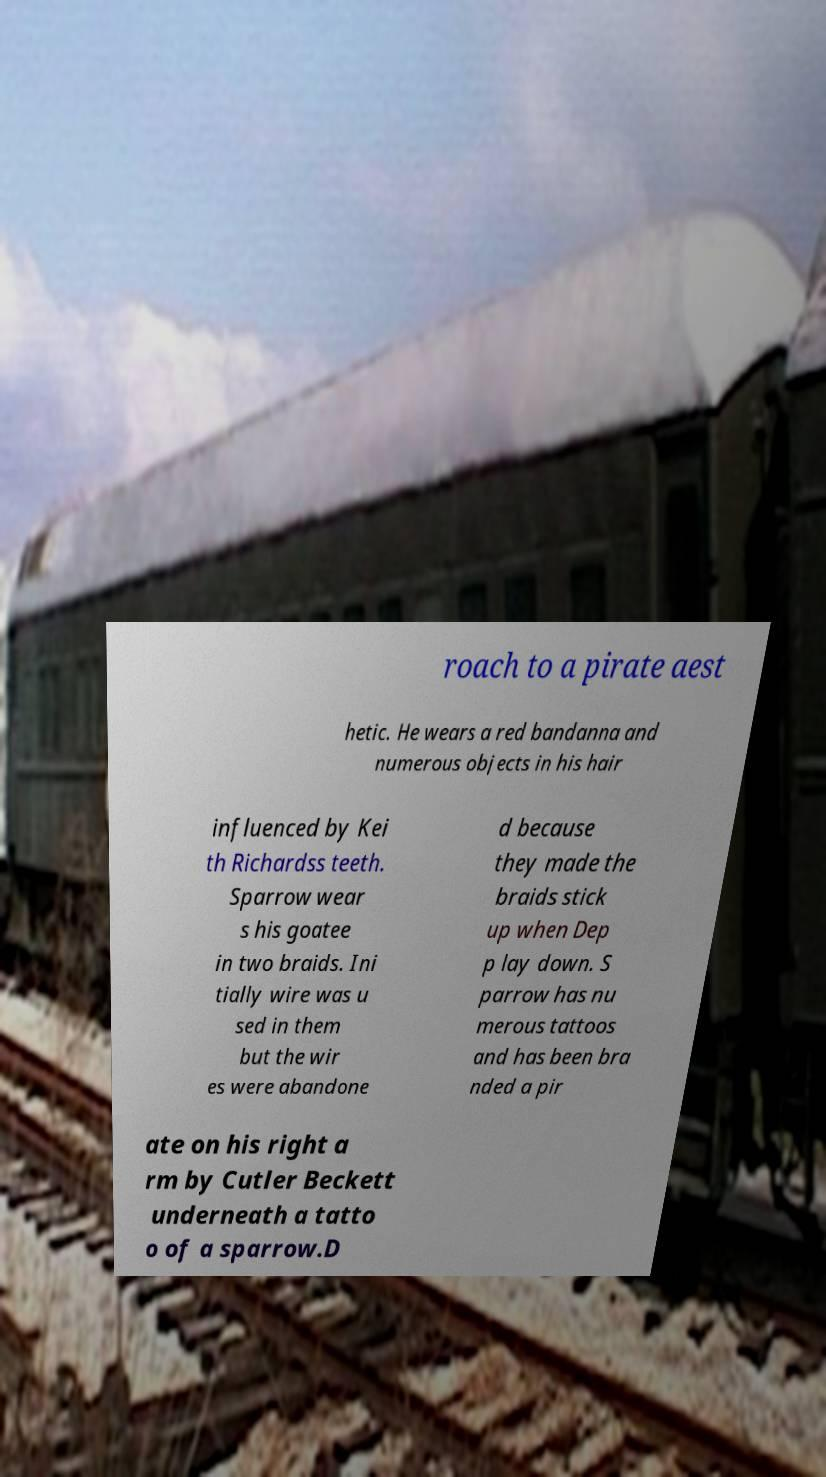There's text embedded in this image that I need extracted. Can you transcribe it verbatim? roach to a pirate aest hetic. He wears a red bandanna and numerous objects in his hair influenced by Kei th Richardss teeth. Sparrow wear s his goatee in two braids. Ini tially wire was u sed in them but the wir es were abandone d because they made the braids stick up when Dep p lay down. S parrow has nu merous tattoos and has been bra nded a pir ate on his right a rm by Cutler Beckett underneath a tatto o of a sparrow.D 